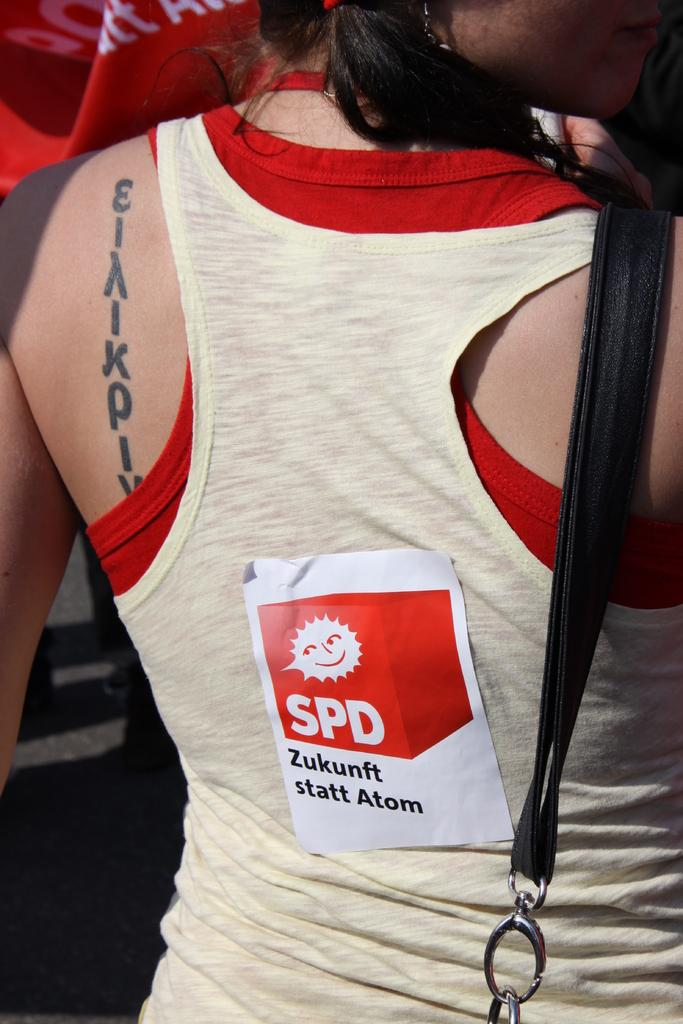<image>
Share a concise interpretation of the image provided. A woman has a sticker on the back of her shirt that says SPD and has a smiling sun. 